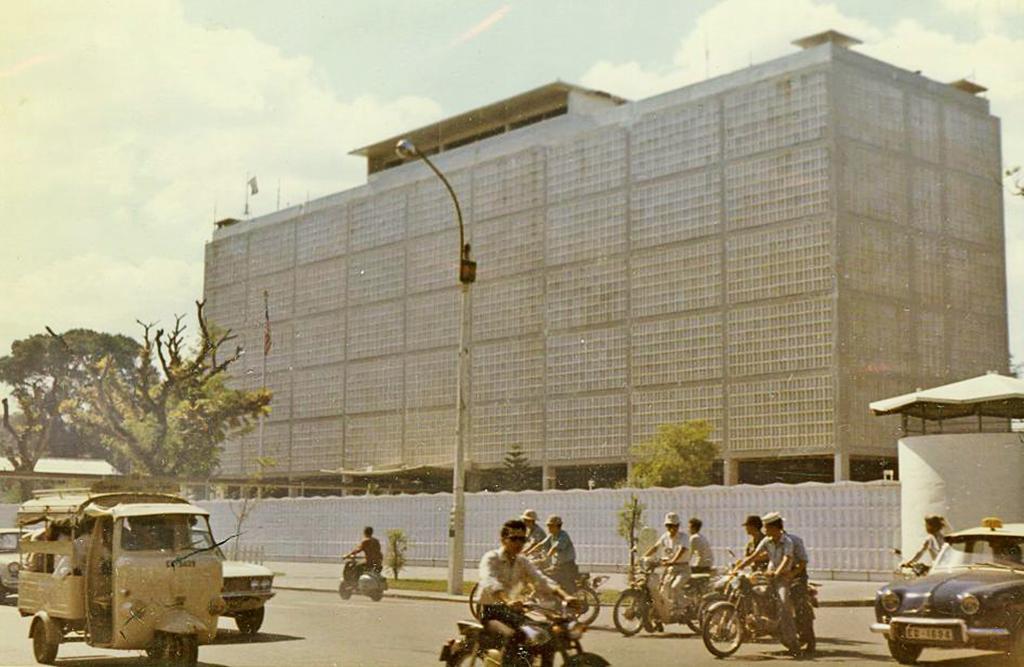In one or two sentences, can you explain what this image depicts? At the bottom of the image there is a road. Here I can see few vehicles and few people are riding the motorcycles. Beside the road there is a light pole and a fencing. In the background there is a building and few trees. At the top of the image I can see the sky and clouds. 